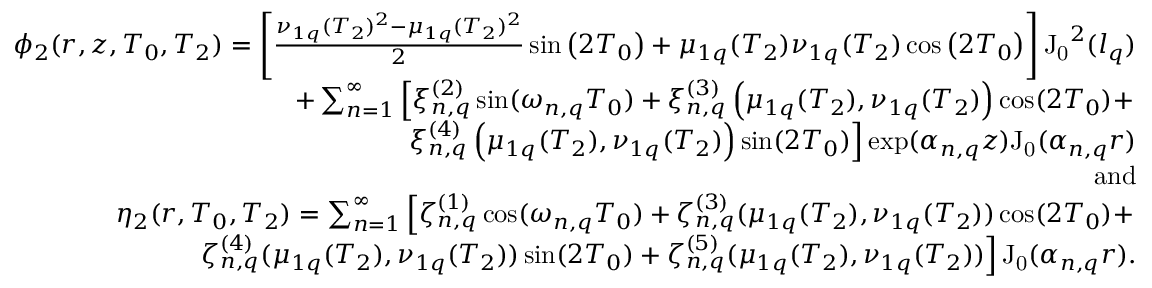<formula> <loc_0><loc_0><loc_500><loc_500>\begin{array} { r l r } & { \phi _ { 2 } ( r , z , T _ { 0 } , T _ { 2 } ) = \left [ \frac { \nu _ { 1 q } ( T _ { 2 } ) ^ { 2 } - \mu _ { 1 q } ( T _ { 2 } ) ^ { 2 } } { 2 } \sin \left ( 2 T _ { 0 } \right ) + \mu _ { 1 q } ( T _ { 2 } ) \nu _ { 1 q } ( T _ { 2 } ) \cos \left ( 2 T _ { 0 } \right ) \right ] J _ { 0 } ^ { 2 } ( l _ { q } ) } \\ & { + \sum _ { n = 1 } ^ { \infty } \left [ \xi _ { n , q } ^ { ( 2 ) } \sin ( \omega _ { n , q } T _ { 0 } ) + \xi _ { n , q } ^ { ( 3 ) } \left ( \mu _ { 1 q } ( T _ { 2 } ) , \nu _ { 1 q } ( T _ { 2 } ) \right ) \cos ( 2 T _ { 0 } ) + } \\ & { \xi _ { n , q } ^ { ( 4 ) } \left ( \mu _ { 1 q } ( T _ { 2 } ) , \nu _ { 1 q } ( T _ { 2 } ) \right ) \sin ( 2 T _ { 0 } ) \right ] \exp ( \alpha _ { n , q } z ) J _ { 0 } ( \alpha _ { n , q } r ) } \\ & { a n d } \\ & { \eta _ { 2 } ( r , T _ { 0 } , T _ { 2 } ) = \sum _ { n = 1 } ^ { \infty } \left [ \zeta _ { n , q } ^ { ( 1 ) } \cos ( \omega _ { n , q } T _ { 0 } ) + \zeta _ { n , q } ^ { ( 3 ) } ( \mu _ { 1 q } ( T _ { 2 } ) , \nu _ { 1 q } ( T _ { 2 } ) ) \cos ( 2 T _ { 0 } ) + } \\ & { \zeta _ { n , q } ^ { ( 4 ) } ( \mu _ { 1 q } ( T _ { 2 } ) , \nu _ { 1 q } ( T _ { 2 } ) ) \sin ( 2 T _ { 0 } ) + \zeta _ { n , q } ^ { ( 5 ) } ( \mu _ { 1 q } ( T _ { 2 } ) , \nu _ { 1 q } ( T _ { 2 } ) ) \right ] J _ { 0 } ( \alpha _ { n , q } r ) . } \end{array}</formula> 